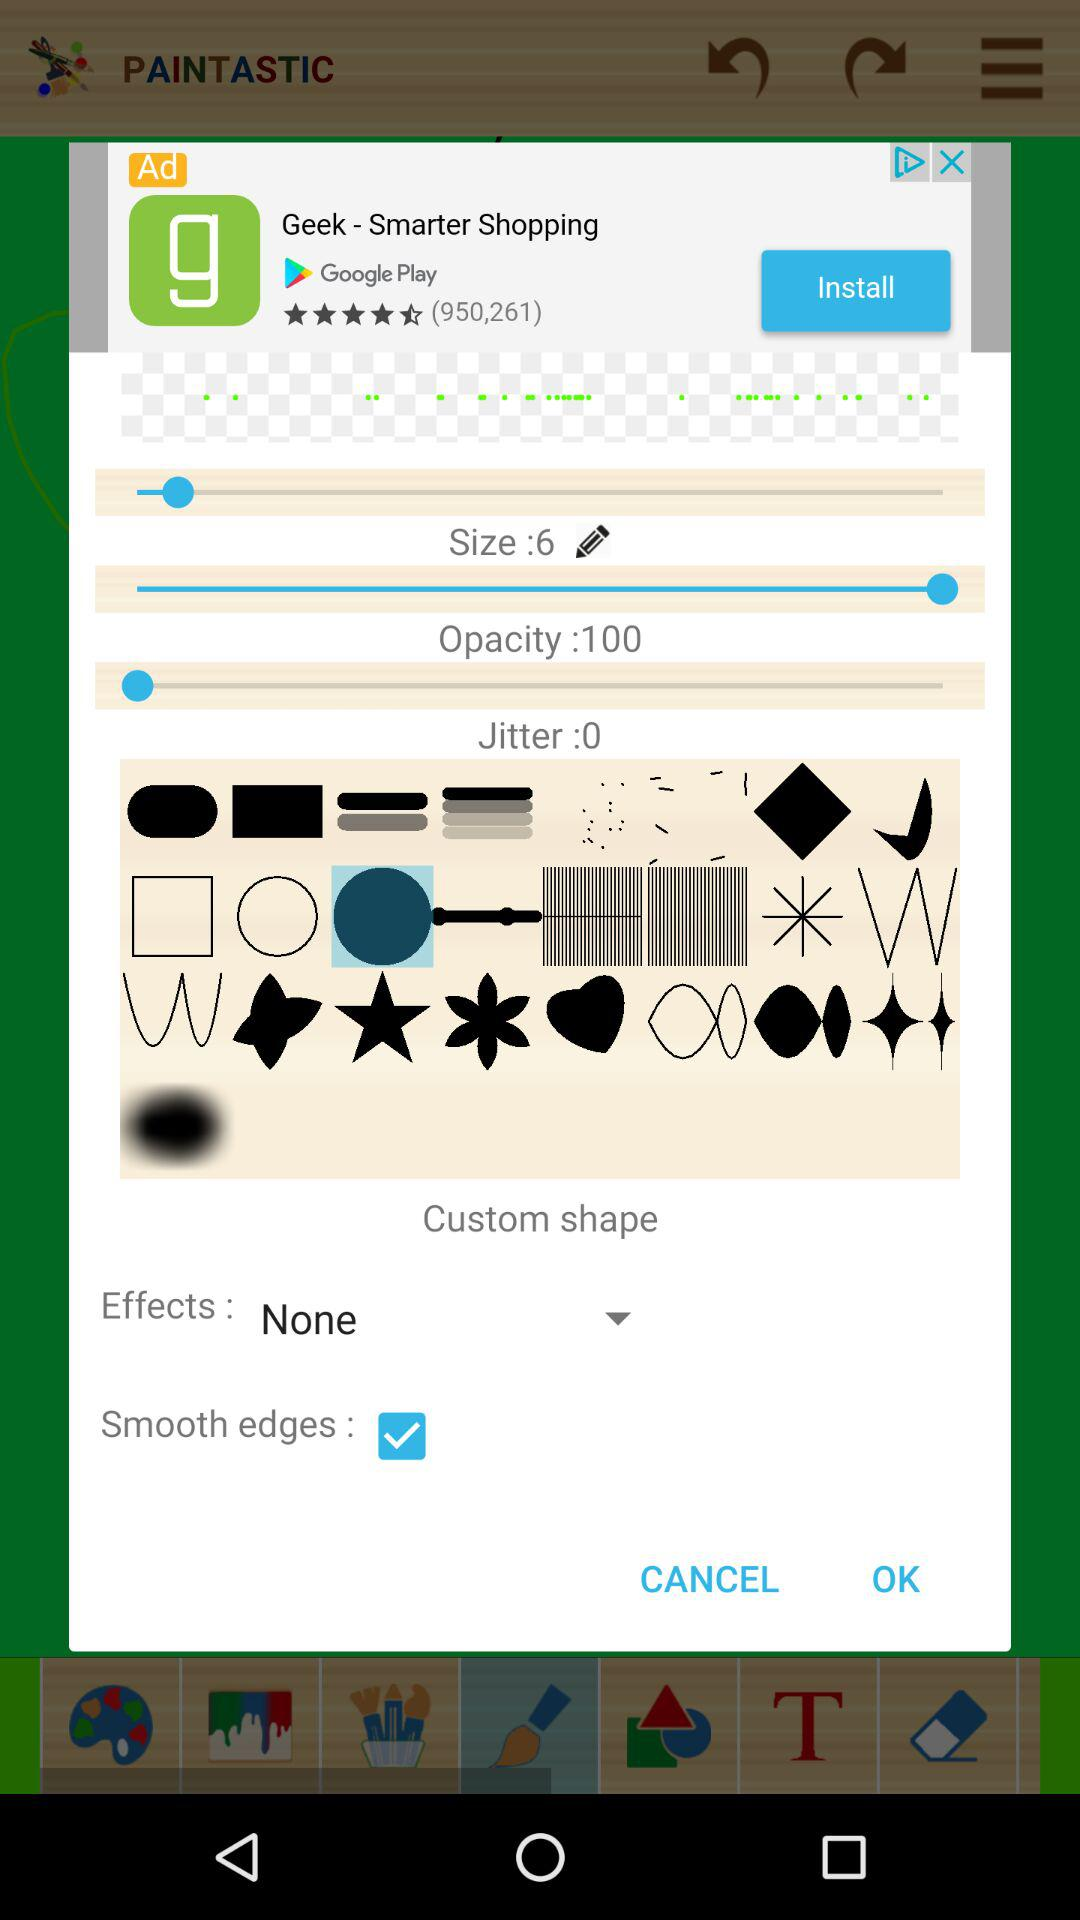If I want to have a custom shape, which effect should I choose?
Answer the question using a single word or phrase. None 